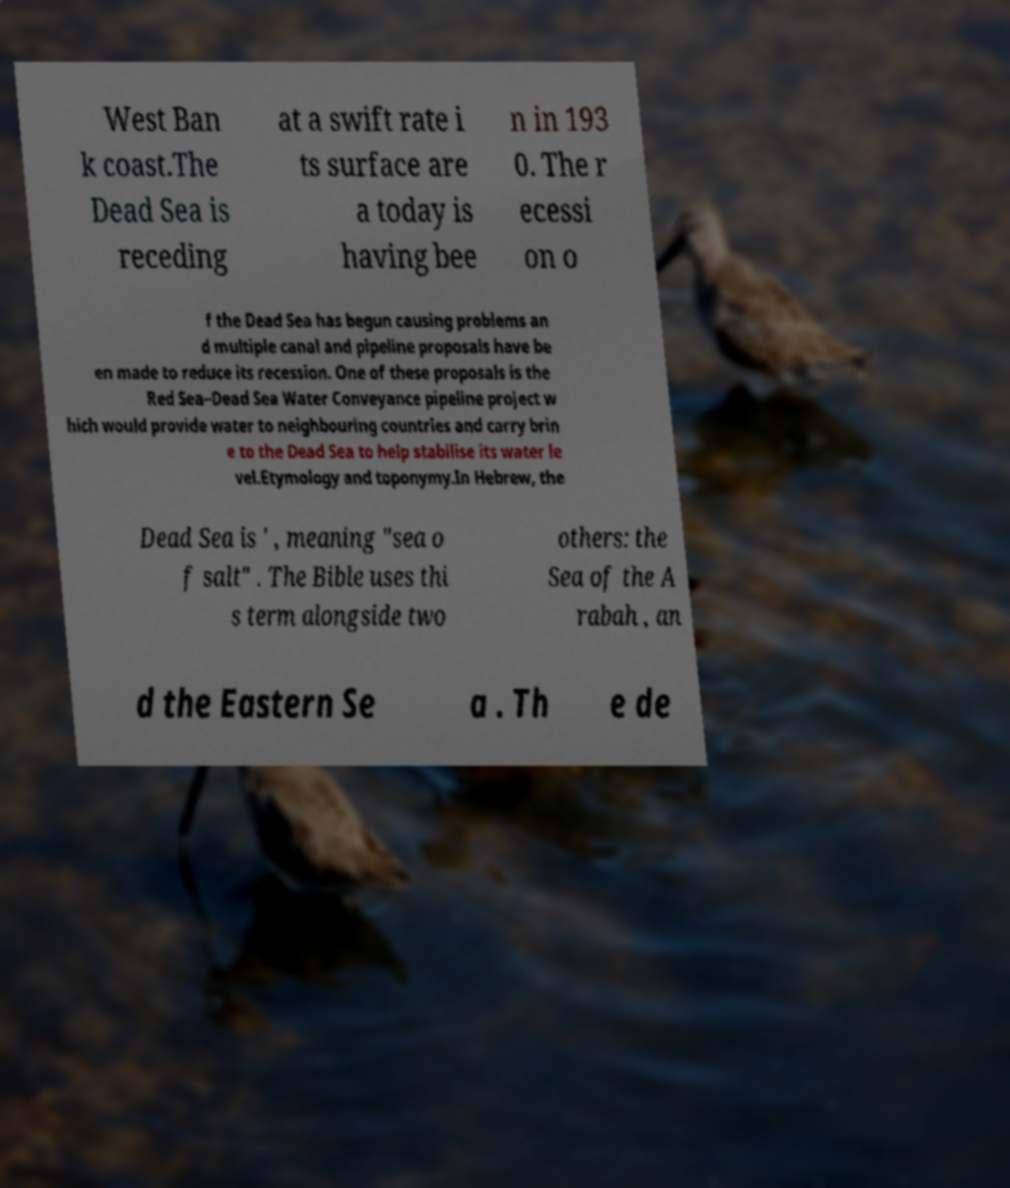Please read and relay the text visible in this image. What does it say? West Ban k coast.The Dead Sea is receding at a swift rate i ts surface are a today is having bee n in 193 0. The r ecessi on o f the Dead Sea has begun causing problems an d multiple canal and pipeline proposals have be en made to reduce its recession. One of these proposals is the Red Sea–Dead Sea Water Conveyance pipeline project w hich would provide water to neighbouring countries and carry brin e to the Dead Sea to help stabilise its water le vel.Etymology and toponymy.In Hebrew, the Dead Sea is ' , meaning "sea o f salt" . The Bible uses thi s term alongside two others: the Sea of the A rabah , an d the Eastern Se a . Th e de 